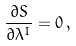<formula> <loc_0><loc_0><loc_500><loc_500>\frac { \partial S } { \partial \lambda ^ { I } } = 0 \, ,</formula> 